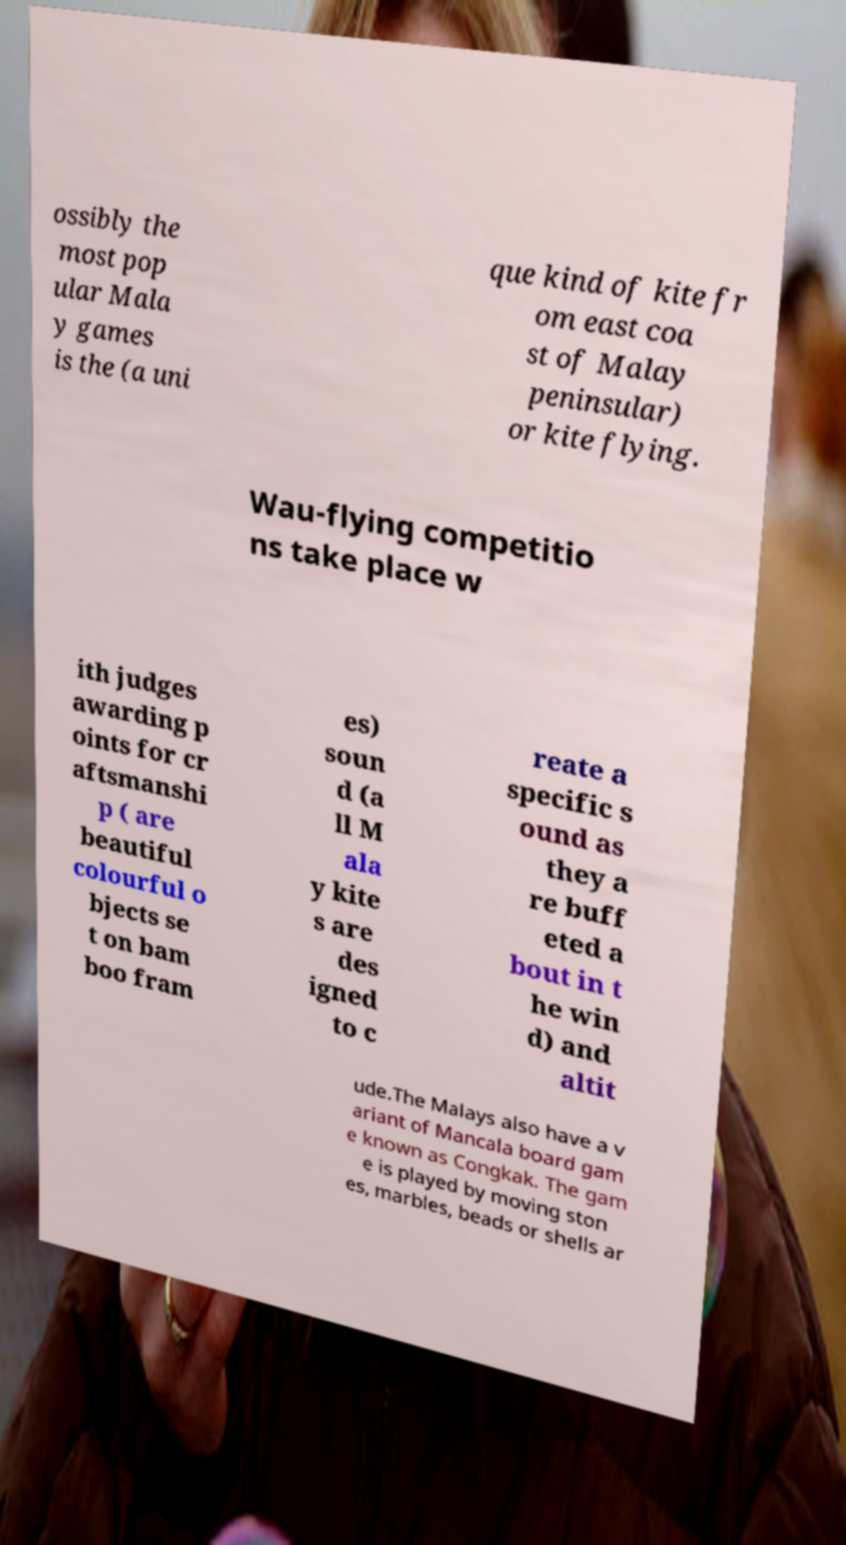Can you read and provide the text displayed in the image?This photo seems to have some interesting text. Can you extract and type it out for me? ossibly the most pop ular Mala y games is the (a uni que kind of kite fr om east coa st of Malay peninsular) or kite flying. Wau-flying competitio ns take place w ith judges awarding p oints for cr aftsmanshi p ( are beautiful colourful o bjects se t on bam boo fram es) soun d (a ll M ala y kite s are des igned to c reate a specific s ound as they a re buff eted a bout in t he win d) and altit ude.The Malays also have a v ariant of Mancala board gam e known as Congkak. The gam e is played by moving ston es, marbles, beads or shells ar 